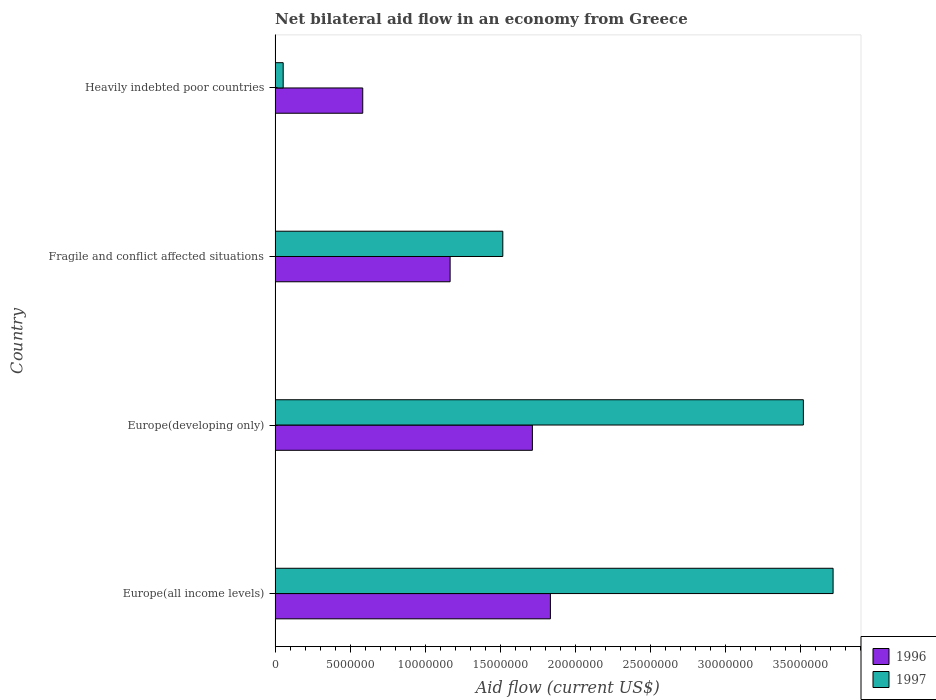How many different coloured bars are there?
Your answer should be compact. 2. Are the number of bars per tick equal to the number of legend labels?
Your answer should be very brief. Yes. Are the number of bars on each tick of the Y-axis equal?
Keep it short and to the point. Yes. How many bars are there on the 4th tick from the bottom?
Ensure brevity in your answer.  2. What is the label of the 4th group of bars from the top?
Your answer should be compact. Europe(all income levels). What is the net bilateral aid flow in 1997 in Heavily indebted poor countries?
Provide a short and direct response. 5.40e+05. Across all countries, what is the maximum net bilateral aid flow in 1997?
Keep it short and to the point. 3.72e+07. Across all countries, what is the minimum net bilateral aid flow in 1996?
Provide a short and direct response. 5.84e+06. In which country was the net bilateral aid flow in 1996 maximum?
Offer a terse response. Europe(all income levels). In which country was the net bilateral aid flow in 1996 minimum?
Ensure brevity in your answer.  Heavily indebted poor countries. What is the total net bilateral aid flow in 1996 in the graph?
Your response must be concise. 5.30e+07. What is the difference between the net bilateral aid flow in 1996 in Europe(developing only) and that in Fragile and conflict affected situations?
Your answer should be very brief. 5.48e+06. What is the difference between the net bilateral aid flow in 1996 in Fragile and conflict affected situations and the net bilateral aid flow in 1997 in Heavily indebted poor countries?
Your answer should be very brief. 1.11e+07. What is the average net bilateral aid flow in 1997 per country?
Provide a succinct answer. 2.20e+07. What is the difference between the net bilateral aid flow in 1997 and net bilateral aid flow in 1996 in Heavily indebted poor countries?
Ensure brevity in your answer.  -5.30e+06. In how many countries, is the net bilateral aid flow in 1996 greater than 27000000 US$?
Keep it short and to the point. 0. What is the ratio of the net bilateral aid flow in 1996 in Europe(all income levels) to that in Heavily indebted poor countries?
Provide a short and direct response. 3.14. Is the net bilateral aid flow in 1996 in Europe(all income levels) less than that in Europe(developing only)?
Ensure brevity in your answer.  No. Is the difference between the net bilateral aid flow in 1997 in Europe(developing only) and Fragile and conflict affected situations greater than the difference between the net bilateral aid flow in 1996 in Europe(developing only) and Fragile and conflict affected situations?
Your answer should be compact. Yes. What is the difference between the highest and the second highest net bilateral aid flow in 1996?
Provide a short and direct response. 1.20e+06. What is the difference between the highest and the lowest net bilateral aid flow in 1997?
Your response must be concise. 3.66e+07. In how many countries, is the net bilateral aid flow in 1996 greater than the average net bilateral aid flow in 1996 taken over all countries?
Your answer should be very brief. 2. Is the sum of the net bilateral aid flow in 1996 in Fragile and conflict affected situations and Heavily indebted poor countries greater than the maximum net bilateral aid flow in 1997 across all countries?
Your response must be concise. No. How many bars are there?
Ensure brevity in your answer.  8. Are all the bars in the graph horizontal?
Your answer should be compact. Yes. Does the graph contain any zero values?
Your response must be concise. No. Does the graph contain grids?
Your response must be concise. No. How are the legend labels stacked?
Provide a succinct answer. Vertical. What is the title of the graph?
Offer a very short reply. Net bilateral aid flow in an economy from Greece. Does "2003" appear as one of the legend labels in the graph?
Your answer should be compact. No. What is the label or title of the X-axis?
Provide a succinct answer. Aid flow (current US$). What is the label or title of the Y-axis?
Your answer should be compact. Country. What is the Aid flow (current US$) of 1996 in Europe(all income levels)?
Offer a terse response. 1.83e+07. What is the Aid flow (current US$) of 1997 in Europe(all income levels)?
Keep it short and to the point. 3.72e+07. What is the Aid flow (current US$) in 1996 in Europe(developing only)?
Make the answer very short. 1.71e+07. What is the Aid flow (current US$) in 1997 in Europe(developing only)?
Offer a very short reply. 3.52e+07. What is the Aid flow (current US$) of 1996 in Fragile and conflict affected situations?
Provide a succinct answer. 1.17e+07. What is the Aid flow (current US$) in 1997 in Fragile and conflict affected situations?
Ensure brevity in your answer.  1.52e+07. What is the Aid flow (current US$) in 1996 in Heavily indebted poor countries?
Keep it short and to the point. 5.84e+06. What is the Aid flow (current US$) in 1997 in Heavily indebted poor countries?
Offer a terse response. 5.40e+05. Across all countries, what is the maximum Aid flow (current US$) of 1996?
Provide a short and direct response. 1.83e+07. Across all countries, what is the maximum Aid flow (current US$) in 1997?
Your response must be concise. 3.72e+07. Across all countries, what is the minimum Aid flow (current US$) in 1996?
Ensure brevity in your answer.  5.84e+06. Across all countries, what is the minimum Aid flow (current US$) in 1997?
Ensure brevity in your answer.  5.40e+05. What is the total Aid flow (current US$) of 1996 in the graph?
Your response must be concise. 5.30e+07. What is the total Aid flow (current US$) of 1997 in the graph?
Your answer should be compact. 8.81e+07. What is the difference between the Aid flow (current US$) of 1996 in Europe(all income levels) and that in Europe(developing only)?
Provide a succinct answer. 1.20e+06. What is the difference between the Aid flow (current US$) in 1997 in Europe(all income levels) and that in Europe(developing only)?
Provide a short and direct response. 1.98e+06. What is the difference between the Aid flow (current US$) in 1996 in Europe(all income levels) and that in Fragile and conflict affected situations?
Offer a very short reply. 6.68e+06. What is the difference between the Aid flow (current US$) in 1997 in Europe(all income levels) and that in Fragile and conflict affected situations?
Offer a very short reply. 2.20e+07. What is the difference between the Aid flow (current US$) in 1996 in Europe(all income levels) and that in Heavily indebted poor countries?
Give a very brief answer. 1.25e+07. What is the difference between the Aid flow (current US$) in 1997 in Europe(all income levels) and that in Heavily indebted poor countries?
Make the answer very short. 3.66e+07. What is the difference between the Aid flow (current US$) in 1996 in Europe(developing only) and that in Fragile and conflict affected situations?
Ensure brevity in your answer.  5.48e+06. What is the difference between the Aid flow (current US$) of 1997 in Europe(developing only) and that in Fragile and conflict affected situations?
Give a very brief answer. 2.00e+07. What is the difference between the Aid flow (current US$) of 1996 in Europe(developing only) and that in Heavily indebted poor countries?
Your response must be concise. 1.13e+07. What is the difference between the Aid flow (current US$) of 1997 in Europe(developing only) and that in Heavily indebted poor countries?
Your response must be concise. 3.46e+07. What is the difference between the Aid flow (current US$) of 1996 in Fragile and conflict affected situations and that in Heavily indebted poor countries?
Ensure brevity in your answer.  5.82e+06. What is the difference between the Aid flow (current US$) in 1997 in Fragile and conflict affected situations and that in Heavily indebted poor countries?
Give a very brief answer. 1.46e+07. What is the difference between the Aid flow (current US$) of 1996 in Europe(all income levels) and the Aid flow (current US$) of 1997 in Europe(developing only)?
Keep it short and to the point. -1.68e+07. What is the difference between the Aid flow (current US$) in 1996 in Europe(all income levels) and the Aid flow (current US$) in 1997 in Fragile and conflict affected situations?
Ensure brevity in your answer.  3.17e+06. What is the difference between the Aid flow (current US$) of 1996 in Europe(all income levels) and the Aid flow (current US$) of 1997 in Heavily indebted poor countries?
Offer a very short reply. 1.78e+07. What is the difference between the Aid flow (current US$) of 1996 in Europe(developing only) and the Aid flow (current US$) of 1997 in Fragile and conflict affected situations?
Make the answer very short. 1.97e+06. What is the difference between the Aid flow (current US$) of 1996 in Europe(developing only) and the Aid flow (current US$) of 1997 in Heavily indebted poor countries?
Your answer should be very brief. 1.66e+07. What is the difference between the Aid flow (current US$) in 1996 in Fragile and conflict affected situations and the Aid flow (current US$) in 1997 in Heavily indebted poor countries?
Offer a very short reply. 1.11e+07. What is the average Aid flow (current US$) in 1996 per country?
Your response must be concise. 1.32e+07. What is the average Aid flow (current US$) in 1997 per country?
Make the answer very short. 2.20e+07. What is the difference between the Aid flow (current US$) in 1996 and Aid flow (current US$) in 1997 in Europe(all income levels)?
Give a very brief answer. -1.88e+07. What is the difference between the Aid flow (current US$) in 1996 and Aid flow (current US$) in 1997 in Europe(developing only)?
Provide a succinct answer. -1.80e+07. What is the difference between the Aid flow (current US$) in 1996 and Aid flow (current US$) in 1997 in Fragile and conflict affected situations?
Provide a short and direct response. -3.51e+06. What is the difference between the Aid flow (current US$) in 1996 and Aid flow (current US$) in 1997 in Heavily indebted poor countries?
Your response must be concise. 5.30e+06. What is the ratio of the Aid flow (current US$) in 1996 in Europe(all income levels) to that in Europe(developing only)?
Your response must be concise. 1.07. What is the ratio of the Aid flow (current US$) in 1997 in Europe(all income levels) to that in Europe(developing only)?
Your answer should be compact. 1.06. What is the ratio of the Aid flow (current US$) of 1996 in Europe(all income levels) to that in Fragile and conflict affected situations?
Provide a succinct answer. 1.57. What is the ratio of the Aid flow (current US$) in 1997 in Europe(all income levels) to that in Fragile and conflict affected situations?
Your answer should be compact. 2.45. What is the ratio of the Aid flow (current US$) of 1996 in Europe(all income levels) to that in Heavily indebted poor countries?
Offer a very short reply. 3.14. What is the ratio of the Aid flow (current US$) of 1997 in Europe(all income levels) to that in Heavily indebted poor countries?
Offer a terse response. 68.83. What is the ratio of the Aid flow (current US$) of 1996 in Europe(developing only) to that in Fragile and conflict affected situations?
Keep it short and to the point. 1.47. What is the ratio of the Aid flow (current US$) of 1997 in Europe(developing only) to that in Fragile and conflict affected situations?
Keep it short and to the point. 2.32. What is the ratio of the Aid flow (current US$) of 1996 in Europe(developing only) to that in Heavily indebted poor countries?
Keep it short and to the point. 2.93. What is the ratio of the Aid flow (current US$) in 1997 in Europe(developing only) to that in Heavily indebted poor countries?
Provide a succinct answer. 65.17. What is the ratio of the Aid flow (current US$) in 1996 in Fragile and conflict affected situations to that in Heavily indebted poor countries?
Ensure brevity in your answer.  2. What is the ratio of the Aid flow (current US$) of 1997 in Fragile and conflict affected situations to that in Heavily indebted poor countries?
Offer a very short reply. 28.09. What is the difference between the highest and the second highest Aid flow (current US$) of 1996?
Your answer should be very brief. 1.20e+06. What is the difference between the highest and the second highest Aid flow (current US$) in 1997?
Give a very brief answer. 1.98e+06. What is the difference between the highest and the lowest Aid flow (current US$) in 1996?
Your response must be concise. 1.25e+07. What is the difference between the highest and the lowest Aid flow (current US$) of 1997?
Ensure brevity in your answer.  3.66e+07. 